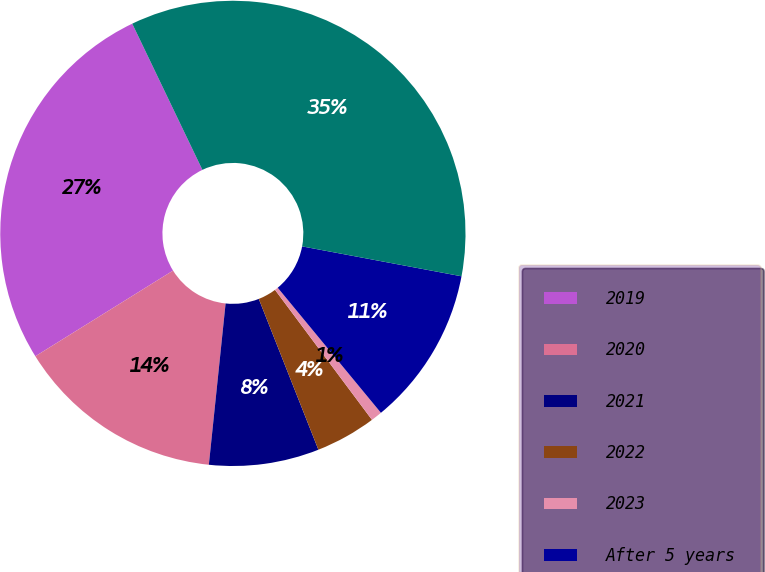Convert chart. <chart><loc_0><loc_0><loc_500><loc_500><pie_chart><fcel>2019<fcel>2020<fcel>2021<fcel>2022<fcel>2023<fcel>After 5 years<fcel>Total<nl><fcel>26.74%<fcel>14.5%<fcel>7.64%<fcel>4.21%<fcel>0.78%<fcel>11.07%<fcel>35.08%<nl></chart> 